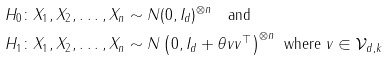<formula> <loc_0><loc_0><loc_500><loc_500>& H _ { 0 } \colon X _ { 1 } , X _ { 2 } , \dots , X _ { n } \sim N ( 0 , I _ { d } ) ^ { \otimes n } \quad \text {and} \\ & H _ { 1 } \colon X _ { 1 } , X _ { 2 } , \dots , X _ { n } \sim N \left ( 0 , I _ { d } + \theta v v ^ { \top } \right ) ^ { \otimes n } \text { where } v \in \mathcal { V } _ { d , k }</formula> 